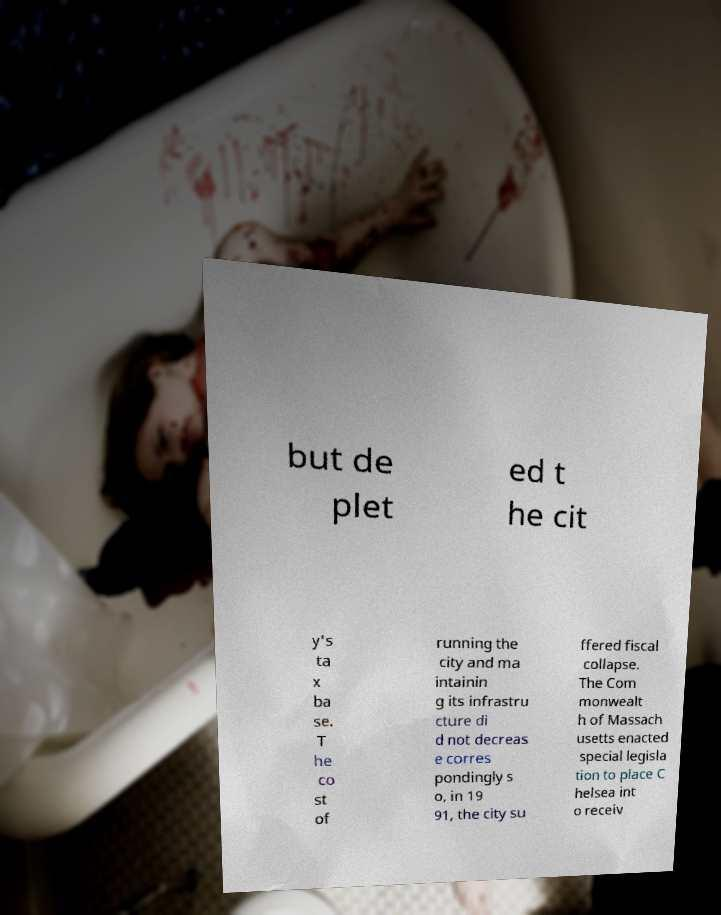I need the written content from this picture converted into text. Can you do that? but de plet ed t he cit y's ta x ba se. T he co st of running the city and ma intainin g its infrastru cture di d not decreas e corres pondingly s o, in 19 91, the city su ffered fiscal collapse. The Com monwealt h of Massach usetts enacted special legisla tion to place C helsea int o receiv 